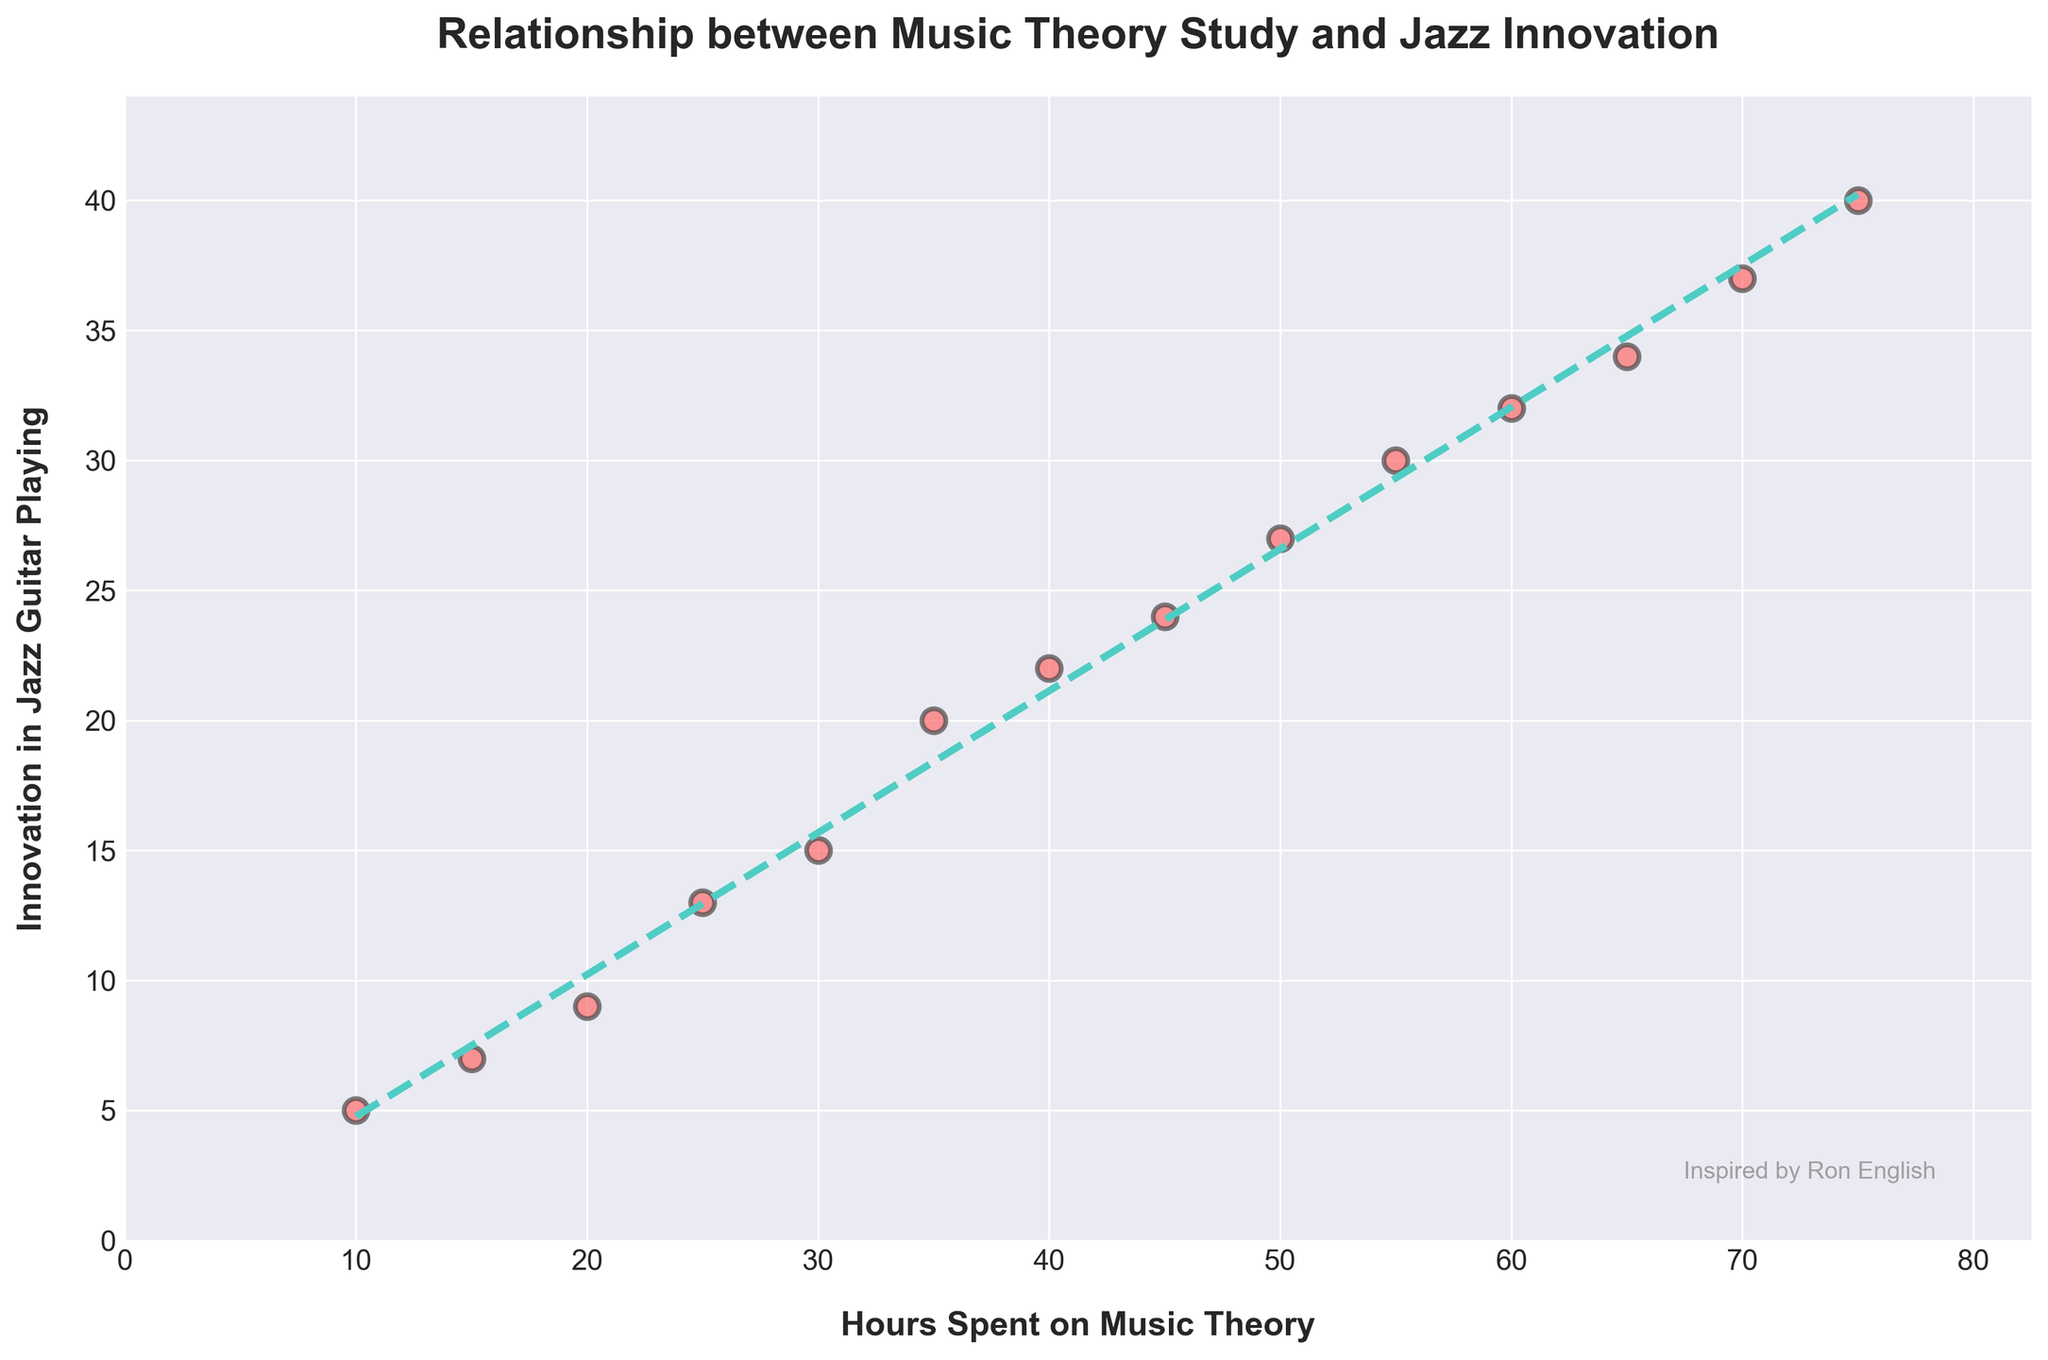How many data points are in the scatter plot? The scatter plot contains several individual markers representing data points. By counting the markers, you can determine there are 14 data points.
Answer: 14 What are the labels of the x-axis and y-axis? The labels can be found on the axes themselves. The x-axis is labeled "Hours Spent on Music Theory," and the y-axis is labeled "Innovation in Jazz Guitar Playing."
Answer: "Hours Spent on Music Theory" and "Innovation in Jazz Guitar Playing" What is the title of the scatter plot? The title appears at the top of the scatter plot, describing its purpose. It is "Relationship between Music Theory Study and Jazz Innovation."
Answer: "Relationship between Music Theory Study and Jazz Innovation" How is the trend line styled in the scatter plot? The trend line is drawn through the data points with a specific style. It is a dashed line and has a color close to teal.
Answer: Dashed line, teal color Does increasing the hours spent on music theory consistently increase innovation in jazz guitar playing according to the trend line? By observing the direction and slope of the trend line, you can see that it ascends from left to right, indicating that more hours spent on music theory generally lead to higher innovation in jazz guitar playing.
Answer: Yes What is the approximate innovation level when 40 hours are spent on music theory? By finding the point on the x-axis corresponding to 40 hours and following it up to where it meets the trend line, you can estimate the y-value, which is around 22.
Answer: 22 What is the difference in innovation levels between 30 hours and 60 hours spent on music theory? Locate the innovation levels for 30 hours (about 15) and 60 hours (about 32) on the y-axis and subtract 15 from 32 to find the difference.
Answer: 17 How does the scatter plot incorporate a tribute to Ron English? The tribute is found as a watermark text in the plot, placed at the bottom right corner with the message "Inspired by Ron English."
Answer: "Inspired by Ron English" Which data point has the highest innovation in jazz guitar playing, and what is the corresponding hours spent on music theory? Identify the highest point on the y-axis, which represents the innovation score, and trace it to the corresponding x-value. The highest innovation is 40, corresponding to 75 hours.
Answer: 40, 75 What is the general shape of the scatter plot's data distribution, and what does it suggest? The scatter plot data points form an upward trend, implying that as the hours spent on music theory increase, so does the innovation in jazz guitar playing. This suggests a positive correlation.
Answer: Upward trend, positive correlation 